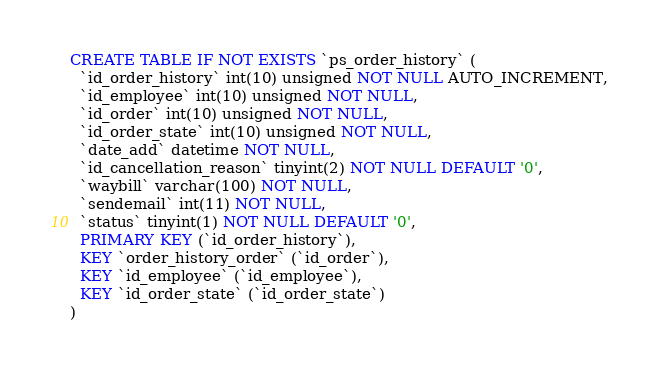<code> <loc_0><loc_0><loc_500><loc_500><_SQL_>CREATE TABLE IF NOT EXISTS `ps_order_history` (
  `id_order_history` int(10) unsigned NOT NULL AUTO_INCREMENT,
  `id_employee` int(10) unsigned NOT NULL,
  `id_order` int(10) unsigned NOT NULL,
  `id_order_state` int(10) unsigned NOT NULL,
  `date_add` datetime NOT NULL,
  `id_cancellation_reason` tinyint(2) NOT NULL DEFAULT '0',
  `waybill` varchar(100) NOT NULL,
  `sendemail` int(11) NOT NULL,
  `status` tinyint(1) NOT NULL DEFAULT '0',
  PRIMARY KEY (`id_order_history`),
  KEY `order_history_order` (`id_order`),
  KEY `id_employee` (`id_employee`),
  KEY `id_order_state` (`id_order_state`)
)
</code> 